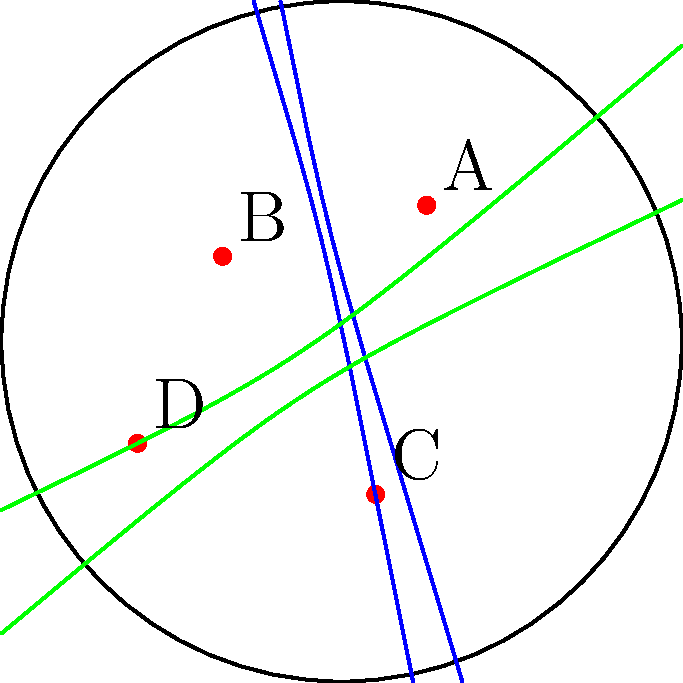In the hyperbolic disc model shown above, four animal species (A, B, C, and D) are represented by red dots. Their migration patterns are depicted by the blue and green hyperbolic arcs. If you were to map a new migration route for species A that passes through the midpoint of the hyperbolic arc between B and C, what would be the approximate angle (in degrees) between this new route and the existing blue arc at point A? To solve this problem, we need to follow these steps:

1) First, understand that in hyperbolic geometry, the concept of "straight lines" is represented by arcs of circles that intersect the boundary disc perpendicularly.

2) The blue arc represents a hyperbolic line passing through points A, B, and C.

3) The midpoint of the hyperbolic arc between B and C would lie on this blue arc.

4) A new hyperbolic line (migration route) from A to this midpoint would be represented by another circular arc intersecting the boundary disc perpendicularly.

5) In hyperbolic geometry, the angle between two lines is defined as the Euclidean angle between the tangents to the arcs at their intersection point.

6) Visually estimating from the diagram, the new arc would intersect the blue arc at point A at an angle of approximately 30-40 degrees.

7) This is because the new arc would need to curve towards the center of the disc to reach the midpoint between B and C, creating an acute angle with the existing blue arc.

8) Given the artistic nature of the persona, an exact calculation is not necessary. The visual estimation and understanding of the hyperbolic disc model are more important.
Answer: Approximately 35° 